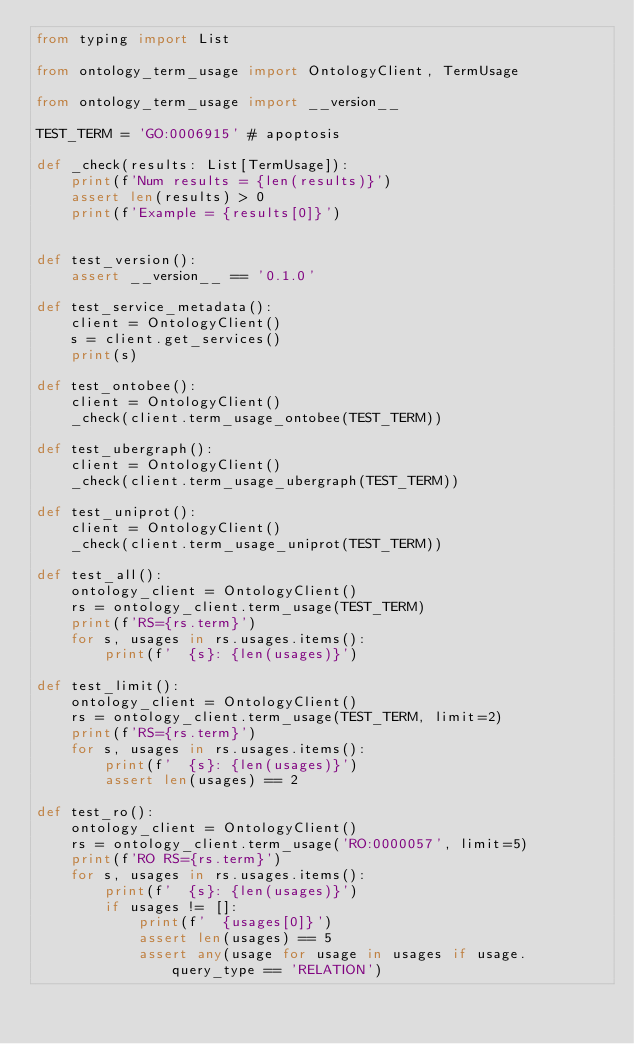<code> <loc_0><loc_0><loc_500><loc_500><_Python_>from typing import List

from ontology_term_usage import OntologyClient, TermUsage

from ontology_term_usage import __version__

TEST_TERM = 'GO:0006915' # apoptosis

def _check(results: List[TermUsage]):
    print(f'Num results = {len(results)}')
    assert len(results) > 0
    print(f'Example = {results[0]}')


def test_version():
    assert __version__ == '0.1.0'

def test_service_metadata():
    client = OntologyClient()
    s = client.get_services()
    print(s)

def test_ontobee():
    client = OntologyClient()
    _check(client.term_usage_ontobee(TEST_TERM))

def test_ubergraph():
    client = OntologyClient()
    _check(client.term_usage_ubergraph(TEST_TERM))

def test_uniprot():
    client = OntologyClient()
    _check(client.term_usage_uniprot(TEST_TERM))

def test_all():
    ontology_client = OntologyClient()
    rs = ontology_client.term_usage(TEST_TERM)
    print(f'RS={rs.term}')
    for s, usages in rs.usages.items():
        print(f'  {s}: {len(usages)}')

def test_limit():
    ontology_client = OntologyClient()
    rs = ontology_client.term_usage(TEST_TERM, limit=2)
    print(f'RS={rs.term}')
    for s, usages in rs.usages.items():
        print(f'  {s}: {len(usages)}')
        assert len(usages) == 2

def test_ro():
    ontology_client = OntologyClient()
    rs = ontology_client.term_usage('RO:0000057', limit=5)
    print(f'RO RS={rs.term}')
    for s, usages in rs.usages.items():
        print(f'  {s}: {len(usages)}')
        if usages != []:
            print(f'  {usages[0]}')
            assert len(usages) == 5
            assert any(usage for usage in usages if usage.query_type == 'RELATION')
</code> 